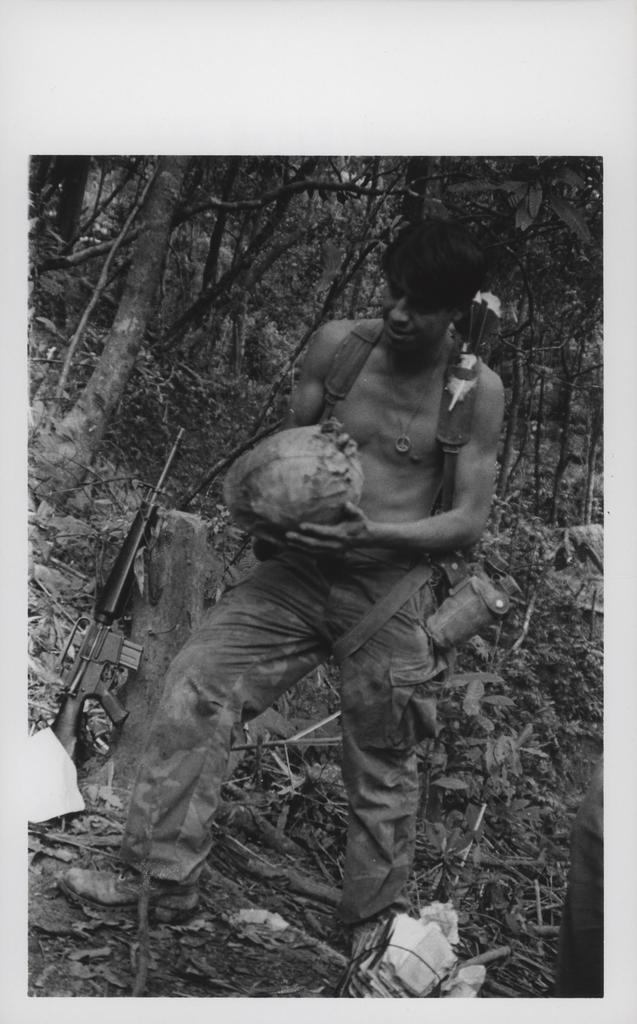Describe this image in one or two sentences. In this image we can see a person standing on the ground and holding an object, there is a tree trunk and gun beside the person and there are few trees in the background. 